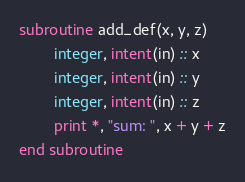Convert code to text. <code><loc_0><loc_0><loc_500><loc_500><_FORTRAN_>subroutine add_def(x, y, z)
        integer, intent(in) :: x
        integer, intent(in) :: y
        integer, intent(in) :: z
        print *, "sum: ", x + y + z
end subroutine</code> 